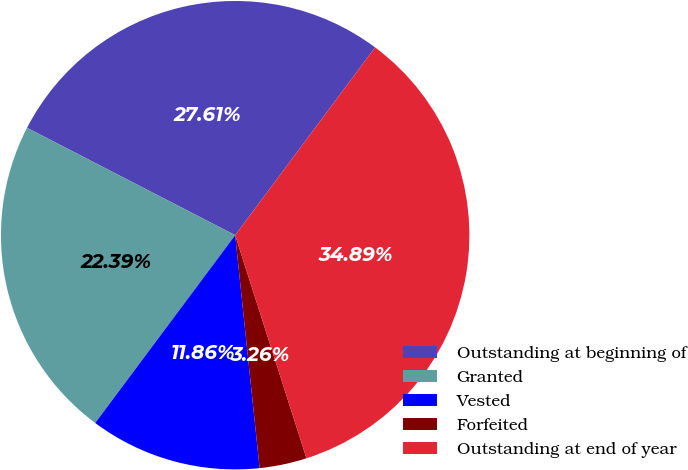Convert chart to OTSL. <chart><loc_0><loc_0><loc_500><loc_500><pie_chart><fcel>Outstanding at beginning of<fcel>Granted<fcel>Vested<fcel>Forfeited<fcel>Outstanding at end of year<nl><fcel>27.61%<fcel>22.39%<fcel>11.86%<fcel>3.26%<fcel>34.89%<nl></chart> 